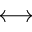Convert formula to latex. <formula><loc_0><loc_0><loc_500><loc_500>\longleftrightarrow</formula> 